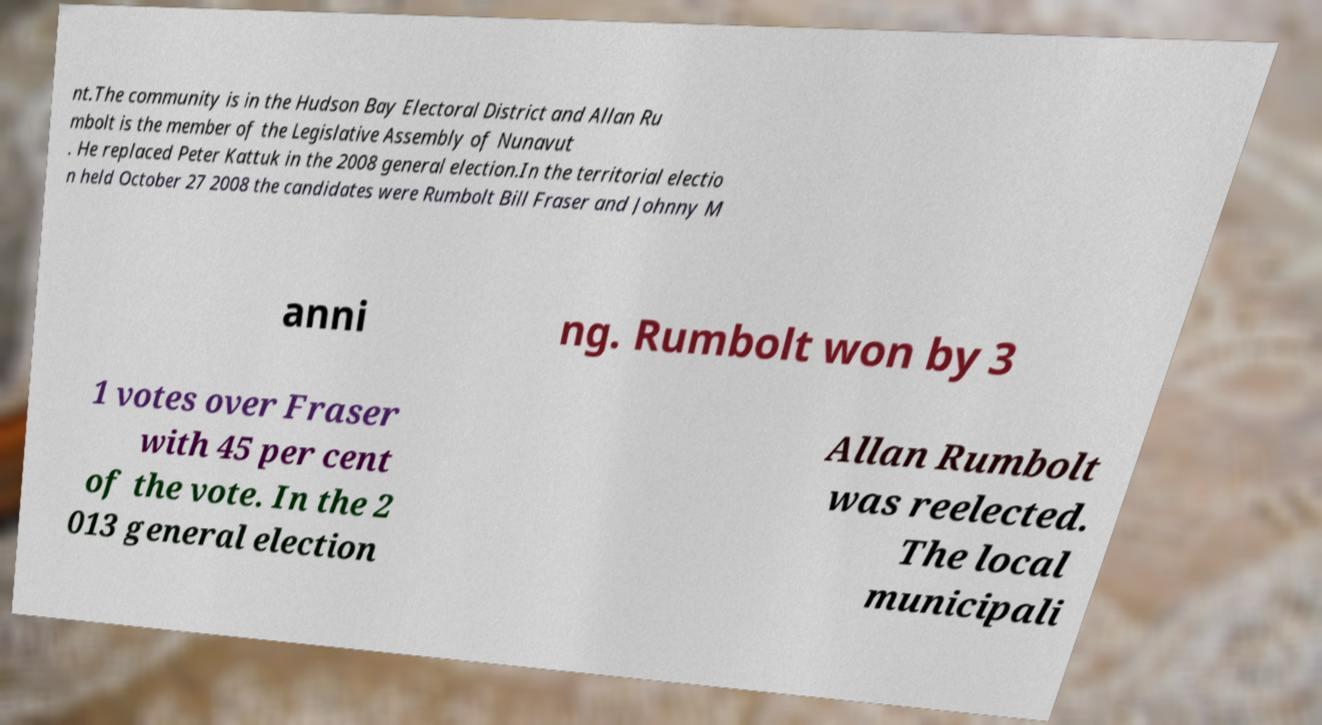Can you read and provide the text displayed in the image?This photo seems to have some interesting text. Can you extract and type it out for me? nt.The community is in the Hudson Bay Electoral District and Allan Ru mbolt is the member of the Legislative Assembly of Nunavut . He replaced Peter Kattuk in the 2008 general election.In the territorial electio n held October 27 2008 the candidates were Rumbolt Bill Fraser and Johnny M anni ng. Rumbolt won by 3 1 votes over Fraser with 45 per cent of the vote. In the 2 013 general election Allan Rumbolt was reelected. The local municipali 